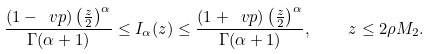Convert formula to latex. <formula><loc_0><loc_0><loc_500><loc_500>\frac { ( 1 - \ v p ) \left ( \frac { z } 2 \right ) ^ { \alpha } } { \Gamma ( \alpha + 1 ) } \leq I _ { \alpha } ( z ) \leq \frac { ( 1 + \ v p ) \left ( \frac { z } 2 \right ) ^ { \alpha } } { \Gamma ( \alpha + 1 ) } , \quad z \leq 2 \rho M _ { 2 } .</formula> 